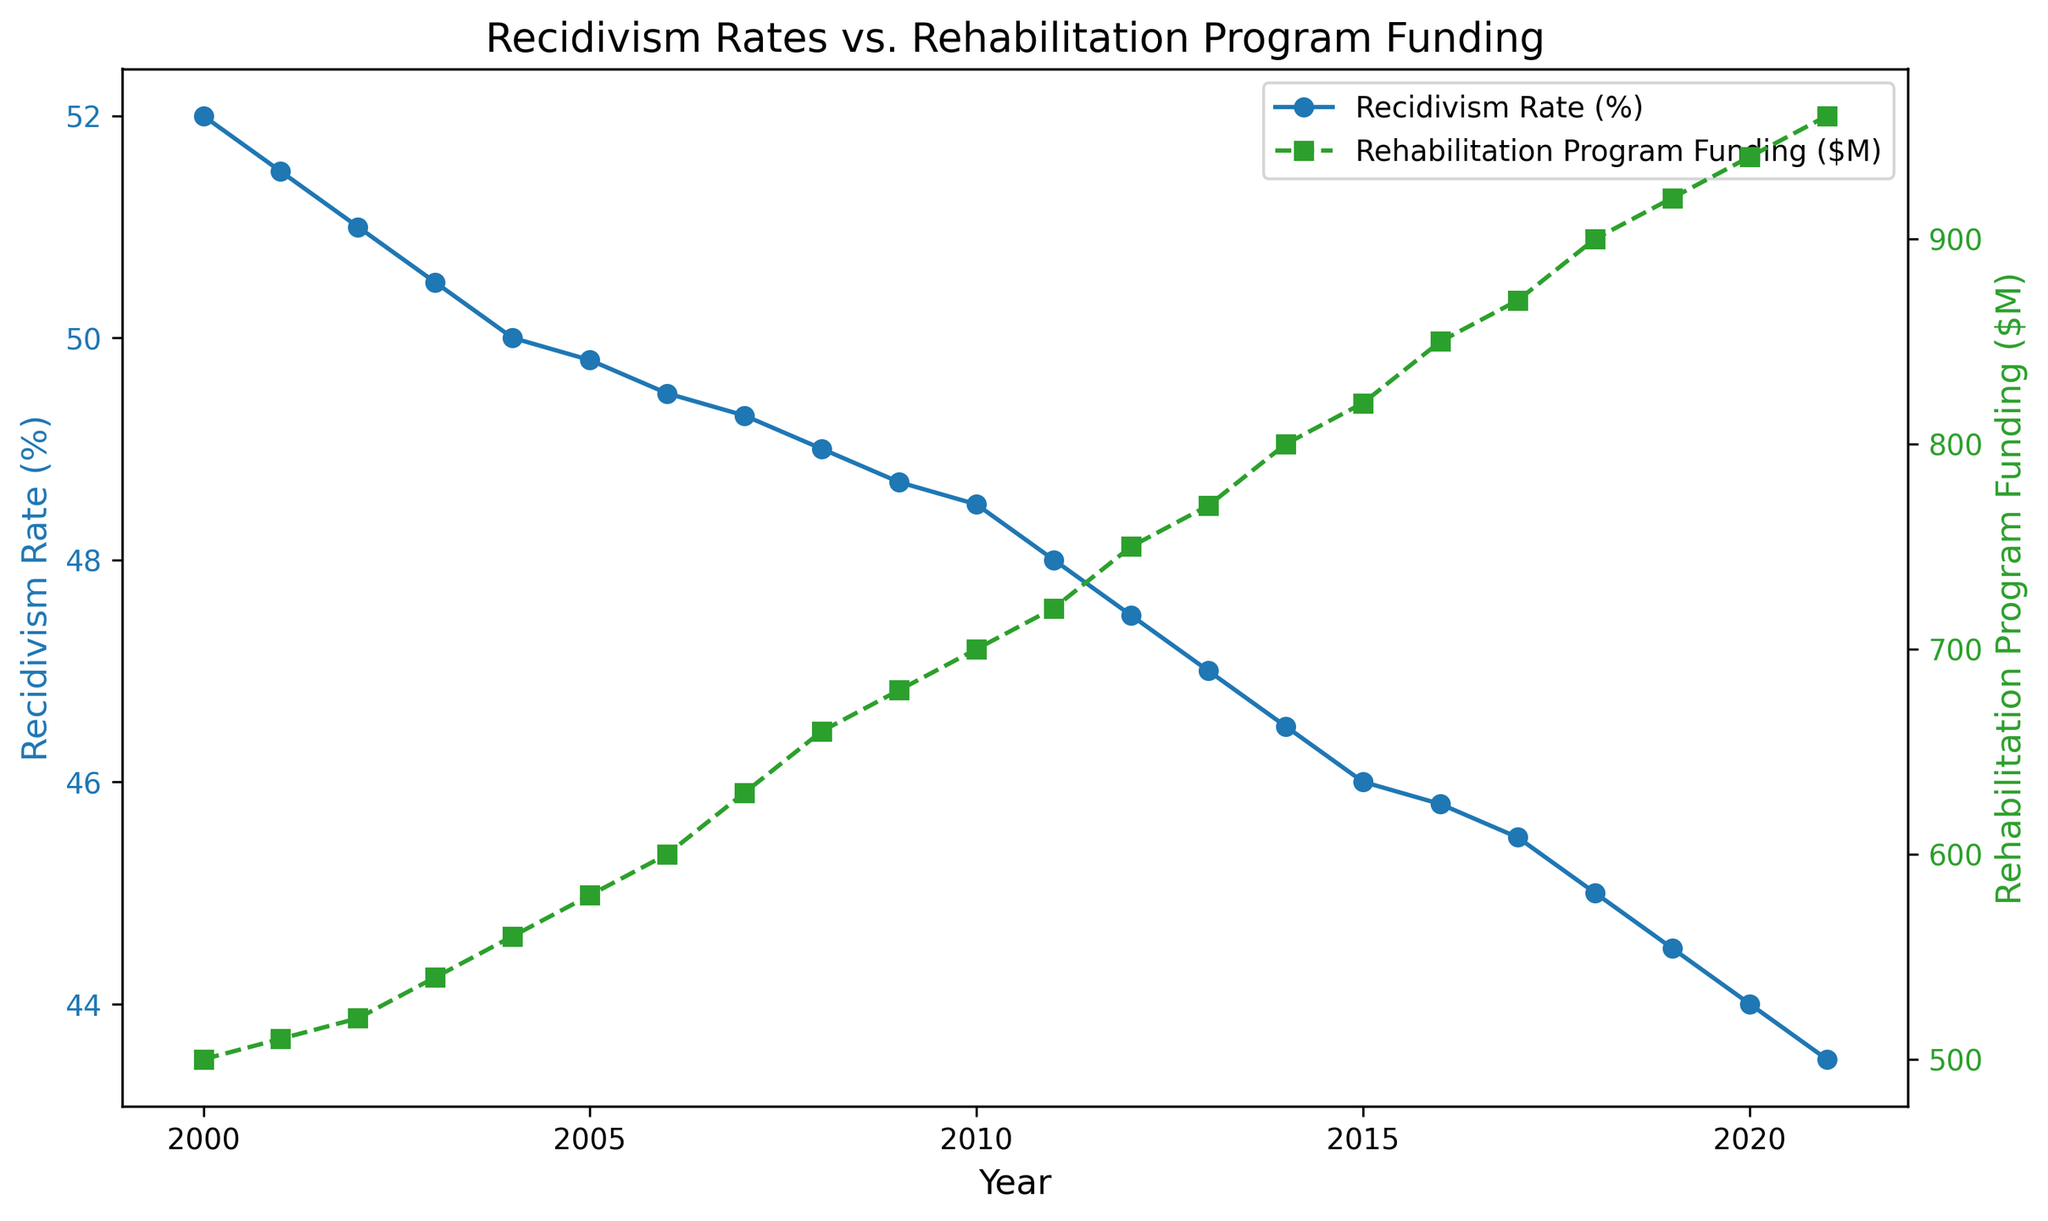What general trend is observed in the recidivism rate from 2000 to 2021? To identify the trend, look at the blue line representing the recidivism rate over the years. It starts at 52% in 2000 and decreases over time, reaching 43.5% in 2021.
Answer: The recidivism rate generally decreases How does the trend in rehabilitation program funding compare to the trend in recidivism rates over the same period? The green line representing funding shows an upward trend starting from $500 million in 2000 and reaching $960 million in 2021, whereas the recidivism rate (blue line) shows a downward trend.
Answer: Rehabilitation program funding increases while the recidivism rate decreases What is the difference in the recidivism rate between 2000 and 2021? The recidivism rate in 2000 is 52%, and in 2021 it is 43.5%. The difference is 52% - 43.5%.
Answer: 8.5% By how much did rehabilitation program funding increase from 2000 to 2021? Rehabilitation program funding in 2000 is $500 million, and in 2021 it is $960 million. The difference is $960 million - $500 million.
Answer: $460 million Which year saw the steepest decrease in the recidivism rate compared to the previous year? Compare the differences between consecutive years' recidivism rates. The largest drop is between one year and the previous year.
Answer: 2012 What is the average recidivism rate from 2000 to 2021? Sum all the recidivism rates from each year and divide by the number of years (22). (52 + 51.5 + 51 + ... + 43.5) / 22.
Answer: 47.45% What is the ratio of rehabilitation program funding in 2021 to that in 2000? Divide the funding in 2021 by the funding in 2000. $960 million / $500 million.
Answer: 1.92 In which year did the rehabilitation program funding reach $600 million? Identify the year where the green line crosses the $600 million mark.
Answer: 2006 How does the funding amount in 2011 compare to that in 2016? Check the green line values for 2011 and 2016. Funding in 2011 is $720 million and in 2016 is $850 million. Compare the two values.
Answer: It increased by $130 million By what percentage did the recidivism rate decrease from its peak in 2000 to 2021? The peak rate in 2000 is 52%, and in 2021 it is 43.5%. The decrease is 52% - 43.5% = 8.5%. To find the percentage decrease: (8.5 / 52) * 100.
Answer: 16.35% 